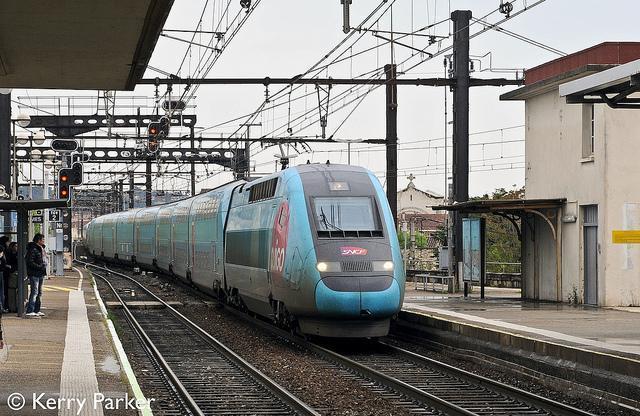The main color of this vehicle is the same color as what?
From the following four choices, select the correct answer to address the question.
Options: Grass, flamingo, daisy, sky. Sky. 